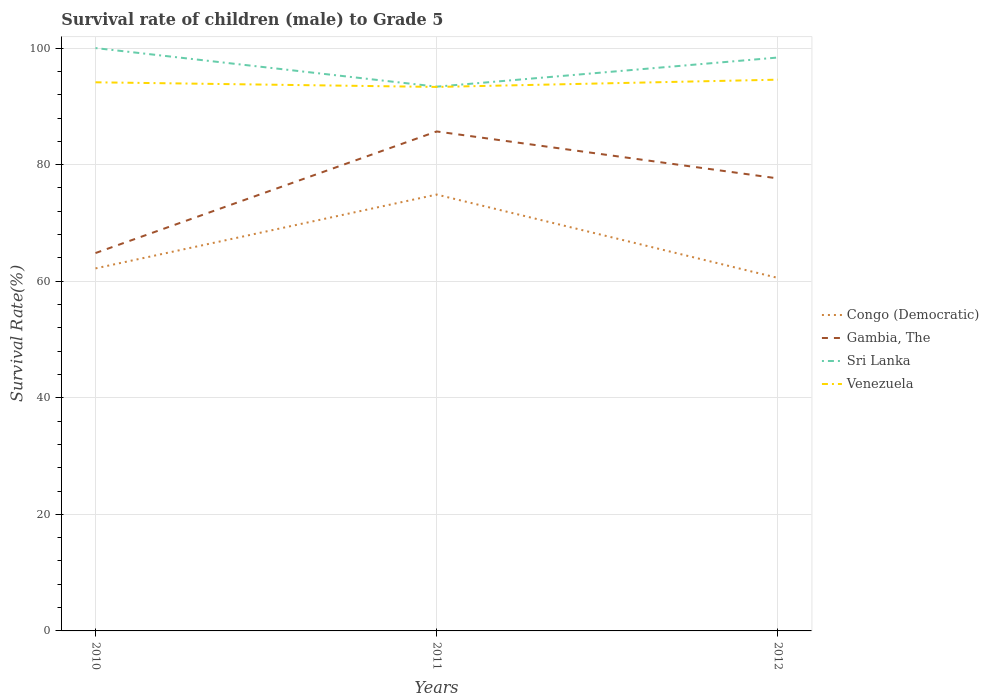How many different coloured lines are there?
Your answer should be compact. 4. Does the line corresponding to Venezuela intersect with the line corresponding to Congo (Democratic)?
Keep it short and to the point. No. Is the number of lines equal to the number of legend labels?
Give a very brief answer. Yes. Across all years, what is the maximum survival rate of male children to grade 5 in Congo (Democratic)?
Your answer should be compact. 60.57. What is the total survival rate of male children to grade 5 in Sri Lanka in the graph?
Your response must be concise. 1.62. What is the difference between the highest and the second highest survival rate of male children to grade 5 in Gambia, The?
Your answer should be compact. 20.86. What is the difference between the highest and the lowest survival rate of male children to grade 5 in Congo (Democratic)?
Your answer should be compact. 1. Is the survival rate of male children to grade 5 in Congo (Democratic) strictly greater than the survival rate of male children to grade 5 in Gambia, The over the years?
Offer a terse response. Yes. What is the difference between two consecutive major ticks on the Y-axis?
Your answer should be compact. 20. Are the values on the major ticks of Y-axis written in scientific E-notation?
Make the answer very short. No. Does the graph contain any zero values?
Ensure brevity in your answer.  No. Does the graph contain grids?
Offer a terse response. Yes. How many legend labels are there?
Provide a succinct answer. 4. What is the title of the graph?
Make the answer very short. Survival rate of children (male) to Grade 5. What is the label or title of the X-axis?
Offer a terse response. Years. What is the label or title of the Y-axis?
Your answer should be compact. Survival Rate(%). What is the Survival Rate(%) of Congo (Democratic) in 2010?
Your answer should be very brief. 62.2. What is the Survival Rate(%) in Gambia, The in 2010?
Your answer should be very brief. 64.83. What is the Survival Rate(%) of Sri Lanka in 2010?
Offer a very short reply. 100. What is the Survival Rate(%) of Venezuela in 2010?
Provide a short and direct response. 94.13. What is the Survival Rate(%) in Congo (Democratic) in 2011?
Keep it short and to the point. 74.87. What is the Survival Rate(%) of Gambia, The in 2011?
Provide a succinct answer. 85.69. What is the Survival Rate(%) in Sri Lanka in 2011?
Your answer should be very brief. 93.38. What is the Survival Rate(%) in Venezuela in 2011?
Ensure brevity in your answer.  93.33. What is the Survival Rate(%) of Congo (Democratic) in 2012?
Offer a very short reply. 60.57. What is the Survival Rate(%) of Gambia, The in 2012?
Offer a terse response. 77.64. What is the Survival Rate(%) of Sri Lanka in 2012?
Your response must be concise. 98.38. What is the Survival Rate(%) in Venezuela in 2012?
Your response must be concise. 94.58. Across all years, what is the maximum Survival Rate(%) of Congo (Democratic)?
Your answer should be compact. 74.87. Across all years, what is the maximum Survival Rate(%) in Gambia, The?
Make the answer very short. 85.69. Across all years, what is the maximum Survival Rate(%) in Sri Lanka?
Give a very brief answer. 100. Across all years, what is the maximum Survival Rate(%) of Venezuela?
Provide a succinct answer. 94.58. Across all years, what is the minimum Survival Rate(%) in Congo (Democratic)?
Offer a very short reply. 60.57. Across all years, what is the minimum Survival Rate(%) of Gambia, The?
Offer a terse response. 64.83. Across all years, what is the minimum Survival Rate(%) of Sri Lanka?
Provide a succinct answer. 93.38. Across all years, what is the minimum Survival Rate(%) in Venezuela?
Offer a very short reply. 93.33. What is the total Survival Rate(%) of Congo (Democratic) in the graph?
Provide a short and direct response. 197.63. What is the total Survival Rate(%) of Gambia, The in the graph?
Provide a short and direct response. 228.16. What is the total Survival Rate(%) of Sri Lanka in the graph?
Give a very brief answer. 291.76. What is the total Survival Rate(%) in Venezuela in the graph?
Offer a terse response. 282.03. What is the difference between the Survival Rate(%) in Congo (Democratic) in 2010 and that in 2011?
Your answer should be compact. -12.67. What is the difference between the Survival Rate(%) of Gambia, The in 2010 and that in 2011?
Offer a terse response. -20.86. What is the difference between the Survival Rate(%) of Sri Lanka in 2010 and that in 2011?
Give a very brief answer. 6.62. What is the difference between the Survival Rate(%) of Venezuela in 2010 and that in 2011?
Your response must be concise. 0.8. What is the difference between the Survival Rate(%) in Congo (Democratic) in 2010 and that in 2012?
Offer a very short reply. 1.63. What is the difference between the Survival Rate(%) in Gambia, The in 2010 and that in 2012?
Your response must be concise. -12.81. What is the difference between the Survival Rate(%) of Sri Lanka in 2010 and that in 2012?
Provide a succinct answer. 1.62. What is the difference between the Survival Rate(%) of Venezuela in 2010 and that in 2012?
Keep it short and to the point. -0.45. What is the difference between the Survival Rate(%) of Congo (Democratic) in 2011 and that in 2012?
Ensure brevity in your answer.  14.3. What is the difference between the Survival Rate(%) of Gambia, The in 2011 and that in 2012?
Make the answer very short. 8.05. What is the difference between the Survival Rate(%) of Sri Lanka in 2011 and that in 2012?
Give a very brief answer. -5. What is the difference between the Survival Rate(%) in Venezuela in 2011 and that in 2012?
Provide a succinct answer. -1.25. What is the difference between the Survival Rate(%) of Congo (Democratic) in 2010 and the Survival Rate(%) of Gambia, The in 2011?
Make the answer very short. -23.5. What is the difference between the Survival Rate(%) of Congo (Democratic) in 2010 and the Survival Rate(%) of Sri Lanka in 2011?
Give a very brief answer. -31.18. What is the difference between the Survival Rate(%) in Congo (Democratic) in 2010 and the Survival Rate(%) in Venezuela in 2011?
Offer a very short reply. -31.13. What is the difference between the Survival Rate(%) of Gambia, The in 2010 and the Survival Rate(%) of Sri Lanka in 2011?
Provide a short and direct response. -28.55. What is the difference between the Survival Rate(%) of Gambia, The in 2010 and the Survival Rate(%) of Venezuela in 2011?
Ensure brevity in your answer.  -28.5. What is the difference between the Survival Rate(%) of Sri Lanka in 2010 and the Survival Rate(%) of Venezuela in 2011?
Keep it short and to the point. 6.67. What is the difference between the Survival Rate(%) in Congo (Democratic) in 2010 and the Survival Rate(%) in Gambia, The in 2012?
Provide a short and direct response. -15.44. What is the difference between the Survival Rate(%) of Congo (Democratic) in 2010 and the Survival Rate(%) of Sri Lanka in 2012?
Provide a short and direct response. -36.18. What is the difference between the Survival Rate(%) of Congo (Democratic) in 2010 and the Survival Rate(%) of Venezuela in 2012?
Ensure brevity in your answer.  -32.38. What is the difference between the Survival Rate(%) in Gambia, The in 2010 and the Survival Rate(%) in Sri Lanka in 2012?
Your answer should be compact. -33.55. What is the difference between the Survival Rate(%) of Gambia, The in 2010 and the Survival Rate(%) of Venezuela in 2012?
Offer a very short reply. -29.75. What is the difference between the Survival Rate(%) of Sri Lanka in 2010 and the Survival Rate(%) of Venezuela in 2012?
Keep it short and to the point. 5.42. What is the difference between the Survival Rate(%) in Congo (Democratic) in 2011 and the Survival Rate(%) in Gambia, The in 2012?
Provide a short and direct response. -2.77. What is the difference between the Survival Rate(%) of Congo (Democratic) in 2011 and the Survival Rate(%) of Sri Lanka in 2012?
Provide a short and direct response. -23.51. What is the difference between the Survival Rate(%) in Congo (Democratic) in 2011 and the Survival Rate(%) in Venezuela in 2012?
Your response must be concise. -19.71. What is the difference between the Survival Rate(%) of Gambia, The in 2011 and the Survival Rate(%) of Sri Lanka in 2012?
Your response must be concise. -12.68. What is the difference between the Survival Rate(%) of Gambia, The in 2011 and the Survival Rate(%) of Venezuela in 2012?
Provide a short and direct response. -8.88. What is the difference between the Survival Rate(%) of Sri Lanka in 2011 and the Survival Rate(%) of Venezuela in 2012?
Ensure brevity in your answer.  -1.2. What is the average Survival Rate(%) in Congo (Democratic) per year?
Ensure brevity in your answer.  65.88. What is the average Survival Rate(%) of Gambia, The per year?
Your response must be concise. 76.05. What is the average Survival Rate(%) of Sri Lanka per year?
Make the answer very short. 97.25. What is the average Survival Rate(%) of Venezuela per year?
Your response must be concise. 94.01. In the year 2010, what is the difference between the Survival Rate(%) of Congo (Democratic) and Survival Rate(%) of Gambia, The?
Offer a terse response. -2.63. In the year 2010, what is the difference between the Survival Rate(%) in Congo (Democratic) and Survival Rate(%) in Sri Lanka?
Provide a short and direct response. -37.8. In the year 2010, what is the difference between the Survival Rate(%) in Congo (Democratic) and Survival Rate(%) in Venezuela?
Make the answer very short. -31.93. In the year 2010, what is the difference between the Survival Rate(%) in Gambia, The and Survival Rate(%) in Sri Lanka?
Make the answer very short. -35.17. In the year 2010, what is the difference between the Survival Rate(%) in Gambia, The and Survival Rate(%) in Venezuela?
Offer a very short reply. -29.3. In the year 2010, what is the difference between the Survival Rate(%) of Sri Lanka and Survival Rate(%) of Venezuela?
Your answer should be compact. 5.87. In the year 2011, what is the difference between the Survival Rate(%) of Congo (Democratic) and Survival Rate(%) of Gambia, The?
Make the answer very short. -10.82. In the year 2011, what is the difference between the Survival Rate(%) in Congo (Democratic) and Survival Rate(%) in Sri Lanka?
Your answer should be compact. -18.51. In the year 2011, what is the difference between the Survival Rate(%) in Congo (Democratic) and Survival Rate(%) in Venezuela?
Make the answer very short. -18.46. In the year 2011, what is the difference between the Survival Rate(%) in Gambia, The and Survival Rate(%) in Sri Lanka?
Provide a succinct answer. -7.68. In the year 2011, what is the difference between the Survival Rate(%) of Gambia, The and Survival Rate(%) of Venezuela?
Offer a very short reply. -7.64. In the year 2011, what is the difference between the Survival Rate(%) in Sri Lanka and Survival Rate(%) in Venezuela?
Give a very brief answer. 0.05. In the year 2012, what is the difference between the Survival Rate(%) of Congo (Democratic) and Survival Rate(%) of Gambia, The?
Your response must be concise. -17.07. In the year 2012, what is the difference between the Survival Rate(%) of Congo (Democratic) and Survival Rate(%) of Sri Lanka?
Provide a succinct answer. -37.81. In the year 2012, what is the difference between the Survival Rate(%) in Congo (Democratic) and Survival Rate(%) in Venezuela?
Your response must be concise. -34.01. In the year 2012, what is the difference between the Survival Rate(%) in Gambia, The and Survival Rate(%) in Sri Lanka?
Make the answer very short. -20.74. In the year 2012, what is the difference between the Survival Rate(%) in Gambia, The and Survival Rate(%) in Venezuela?
Offer a very short reply. -16.94. In the year 2012, what is the difference between the Survival Rate(%) in Sri Lanka and Survival Rate(%) in Venezuela?
Your answer should be compact. 3.8. What is the ratio of the Survival Rate(%) in Congo (Democratic) in 2010 to that in 2011?
Your answer should be very brief. 0.83. What is the ratio of the Survival Rate(%) of Gambia, The in 2010 to that in 2011?
Provide a succinct answer. 0.76. What is the ratio of the Survival Rate(%) in Sri Lanka in 2010 to that in 2011?
Provide a short and direct response. 1.07. What is the ratio of the Survival Rate(%) of Venezuela in 2010 to that in 2011?
Provide a short and direct response. 1.01. What is the ratio of the Survival Rate(%) in Congo (Democratic) in 2010 to that in 2012?
Keep it short and to the point. 1.03. What is the ratio of the Survival Rate(%) in Gambia, The in 2010 to that in 2012?
Make the answer very short. 0.83. What is the ratio of the Survival Rate(%) of Sri Lanka in 2010 to that in 2012?
Provide a short and direct response. 1.02. What is the ratio of the Survival Rate(%) of Congo (Democratic) in 2011 to that in 2012?
Offer a terse response. 1.24. What is the ratio of the Survival Rate(%) in Gambia, The in 2011 to that in 2012?
Your response must be concise. 1.1. What is the ratio of the Survival Rate(%) of Sri Lanka in 2011 to that in 2012?
Give a very brief answer. 0.95. What is the ratio of the Survival Rate(%) of Venezuela in 2011 to that in 2012?
Ensure brevity in your answer.  0.99. What is the difference between the highest and the second highest Survival Rate(%) of Congo (Democratic)?
Your answer should be compact. 12.67. What is the difference between the highest and the second highest Survival Rate(%) of Gambia, The?
Your response must be concise. 8.05. What is the difference between the highest and the second highest Survival Rate(%) of Sri Lanka?
Provide a succinct answer. 1.62. What is the difference between the highest and the second highest Survival Rate(%) in Venezuela?
Make the answer very short. 0.45. What is the difference between the highest and the lowest Survival Rate(%) in Congo (Democratic)?
Offer a very short reply. 14.3. What is the difference between the highest and the lowest Survival Rate(%) of Gambia, The?
Offer a very short reply. 20.86. What is the difference between the highest and the lowest Survival Rate(%) in Sri Lanka?
Provide a short and direct response. 6.62. What is the difference between the highest and the lowest Survival Rate(%) of Venezuela?
Offer a very short reply. 1.25. 